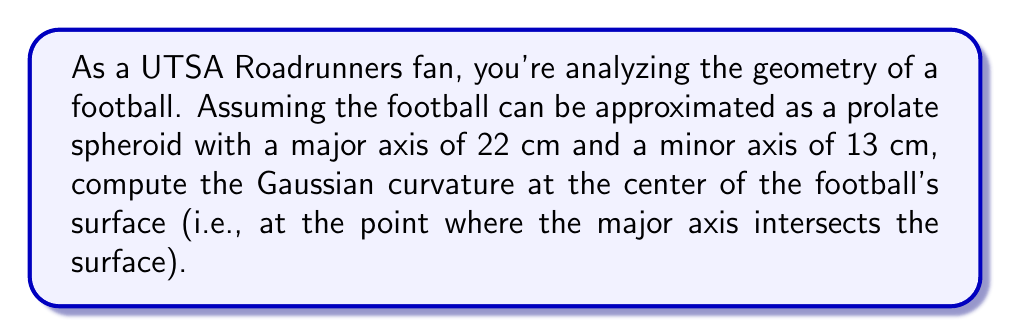Can you answer this question? Let's approach this step-by-step:

1) A prolate spheroid is generated by rotating an ellipse around its major axis. The equation of the spheroid in Cartesian coordinates is:

   $$\frac{x^2}{a^2} + \frac{y^2 + z^2}{b^2} = 1$$

   where $a = 11$ cm (half of the major axis) and $b = 6.5$ cm (half of the minor axis).

2) To compute the Gaussian curvature, we need to find the principal curvatures $\kappa_1$ and $\kappa_2$.

3) For a prolate spheroid, at the point where the major axis intersects the surface (let's call it the "pole"), the principal curvatures are:

   $$\kappa_1 = \frac{b}{a^2}$$
   $$\kappa_2 = \frac{b}{a^2}$$

4) Substituting our values:

   $$\kappa_1 = \kappa_2 = \frac{6.5}{11^2} \approx 0.0537 \text{ cm}^{-1}$$

5) The Gaussian curvature $K$ is the product of the principal curvatures:

   $$K = \kappa_1 \kappa_2 = \left(\frac{b}{a^2}\right)^2 = \left(\frac{6.5}{11^2}\right)^2 \approx 0.00288 \text{ cm}^{-2}$$

6) Convert to m^-2:

   $$K \approx 0.00288 \times 10000 = 28.8 \text{ m}^{-2}$$
Answer: $28.8 \text{ m}^{-2}$ 